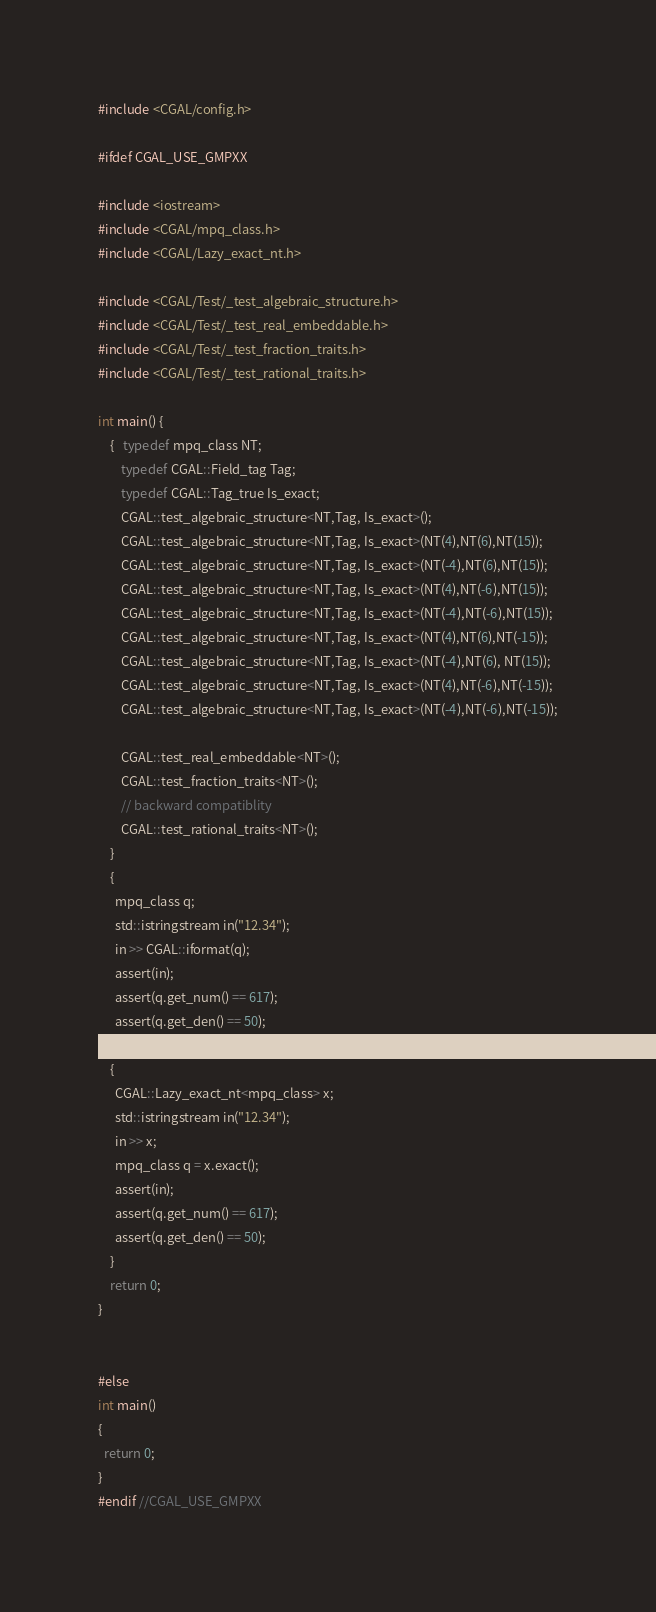<code> <loc_0><loc_0><loc_500><loc_500><_C++_>#include <CGAL/config.h>

#ifdef CGAL_USE_GMPXX

#include <iostream>
#include <CGAL/mpq_class.h>
#include <CGAL/Lazy_exact_nt.h>

#include <CGAL/Test/_test_algebraic_structure.h>
#include <CGAL/Test/_test_real_embeddable.h>
#include <CGAL/Test/_test_fraction_traits.h>
#include <CGAL/Test/_test_rational_traits.h>

int main() {
    {   typedef mpq_class NT;
        typedef CGAL::Field_tag Tag;
        typedef CGAL::Tag_true Is_exact;
        CGAL::test_algebraic_structure<NT,Tag, Is_exact>();
        CGAL::test_algebraic_structure<NT,Tag, Is_exact>(NT(4),NT(6),NT(15));
        CGAL::test_algebraic_structure<NT,Tag, Is_exact>(NT(-4),NT(6),NT(15));
        CGAL::test_algebraic_structure<NT,Tag, Is_exact>(NT(4),NT(-6),NT(15));
        CGAL::test_algebraic_structure<NT,Tag, Is_exact>(NT(-4),NT(-6),NT(15));
        CGAL::test_algebraic_structure<NT,Tag, Is_exact>(NT(4),NT(6),NT(-15));
        CGAL::test_algebraic_structure<NT,Tag, Is_exact>(NT(-4),NT(6), NT(15));
        CGAL::test_algebraic_structure<NT,Tag, Is_exact>(NT(4),NT(-6),NT(-15));
        CGAL::test_algebraic_structure<NT,Tag, Is_exact>(NT(-4),NT(-6),NT(-15));

        CGAL::test_real_embeddable<NT>();
        CGAL::test_fraction_traits<NT>();
        // backward compatiblity
        CGAL::test_rational_traits<NT>();
    }
    {
      mpq_class q;
      std::istringstream in("12.34");
      in >> CGAL::iformat(q);
      assert(in);
      assert(q.get_num() == 617);
      assert(q.get_den() == 50);
    }
    {
      CGAL::Lazy_exact_nt<mpq_class> x;
      std::istringstream in("12.34");
      in >> x;
      mpq_class q = x.exact();
      assert(in);
      assert(q.get_num() == 617);
      assert(q.get_den() == 50);
    }
    return 0;
}


#else
int main()
{
  return 0;
}
#endif //CGAL_USE_GMPXX
</code> 